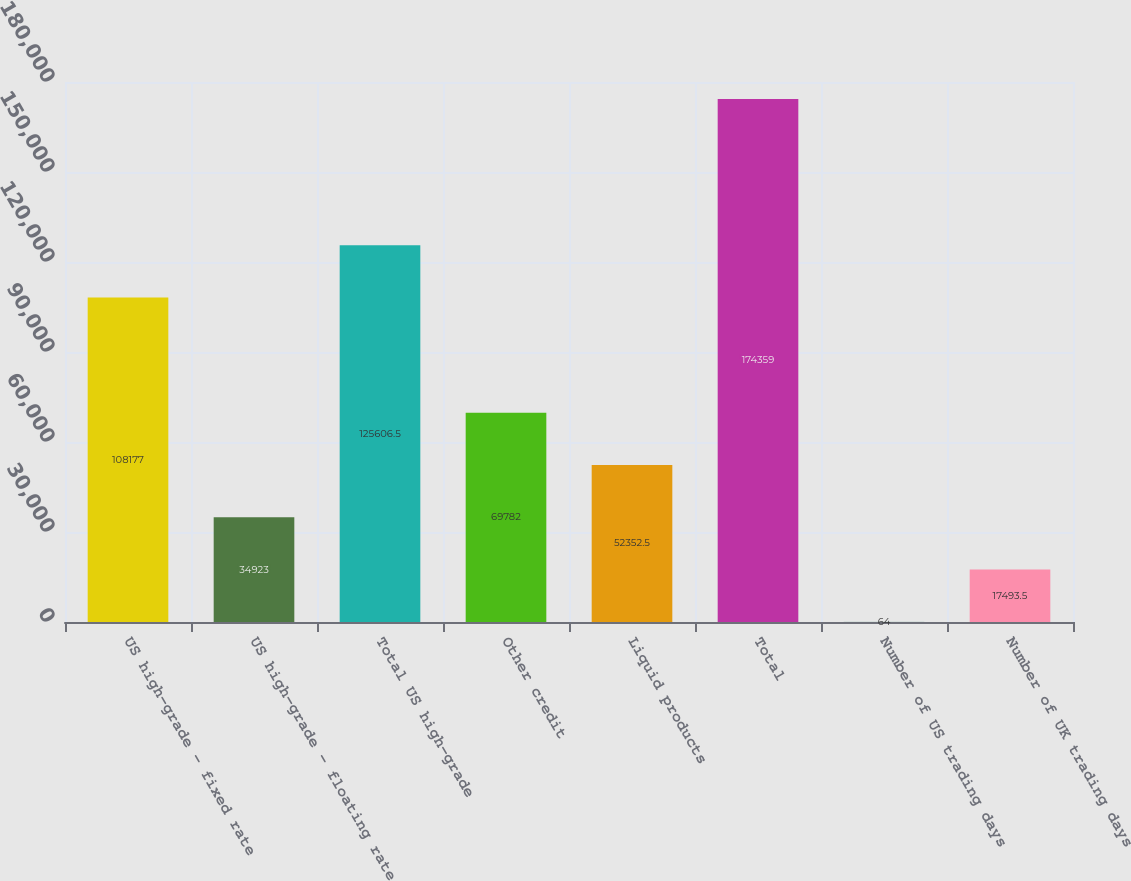Convert chart. <chart><loc_0><loc_0><loc_500><loc_500><bar_chart><fcel>US high-grade - fixed rate<fcel>US high-grade - floating rate<fcel>Total US high-grade<fcel>Other credit<fcel>Liquid products<fcel>Total<fcel>Number of US trading days<fcel>Number of UK trading days<nl><fcel>108177<fcel>34923<fcel>125606<fcel>69782<fcel>52352.5<fcel>174359<fcel>64<fcel>17493.5<nl></chart> 